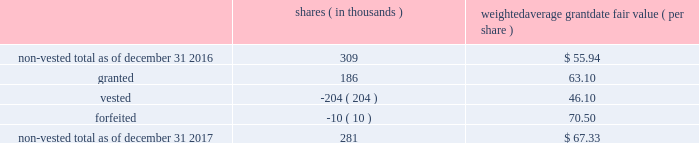The table below summarizes activity of rsus with performance conditions for the year ended december 31 , shares ( in thousands ) weighted average grant date fair value ( per share ) .
As of december 31 , 2017 , $ 6 million of total unrecognized compensation cost related to the nonvested rsus , with and without performance conditions , is expected to be recognized over the weighted-average remaining life of 1.5 years .
The total fair value of rsus , with and without performance conditions , vested was $ 16 million , $ 14 million and $ 12 million for the years ended december 31 , 2017 , 2016 and 2015 , respectively .
If dividends are paid with respect to shares of the company 2019s common stock before the rsus are distributed , the company credits a liability for the value of the dividends that would have been paid if the rsus were shares of company common stock .
When the rsus are distributed , the company pays the participant a lump sum cash payment equal to the value of the dividend equivalents accrued .
The company accrued dividend equivalents totaling less than $ 1 million , $ 1 million and $ 1 million to accumulated deficit in the accompanying consolidated statements of changes in stockholders 2019 equity for the years ended december 31 , 2017 , 2016 and 2015 , respectively .
Employee stock purchase plan the company maintains a nonqualified employee stock purchase plan ( the 201cespp 201d ) through which employee participants may use payroll deductions to acquire company common stock at the lesser of 90% ( 90 % ) of the fair market value of the common stock at either the beginning or the end of a three-month purchase period .
On february 15 , 2017 , the board adopted the american water works company , inc .
And its designated subsidiaries 2017 nonqualified employee stock purchase plan , which was approved by stockholders on may 12 , 2017 and took effect on august 5 , 2017 .
The prior plan was terminated as to new purchases of company stock effective august 31 , 2017 .
As of december 31 , 2017 , there were 2.0 million shares of common stock reserved for issuance under the espp .
The espp is considered compensatory .
During the years ended december 31 , 2017 , 2016 and 2015 , the company issued 93 thousand , 93 thousand and 98 thousand shares , respectively , under the espp. .
As of december 31 , 2017 what was the percent of shares forfeited? 
Computations: (10 / 281)
Answer: 0.03559. 